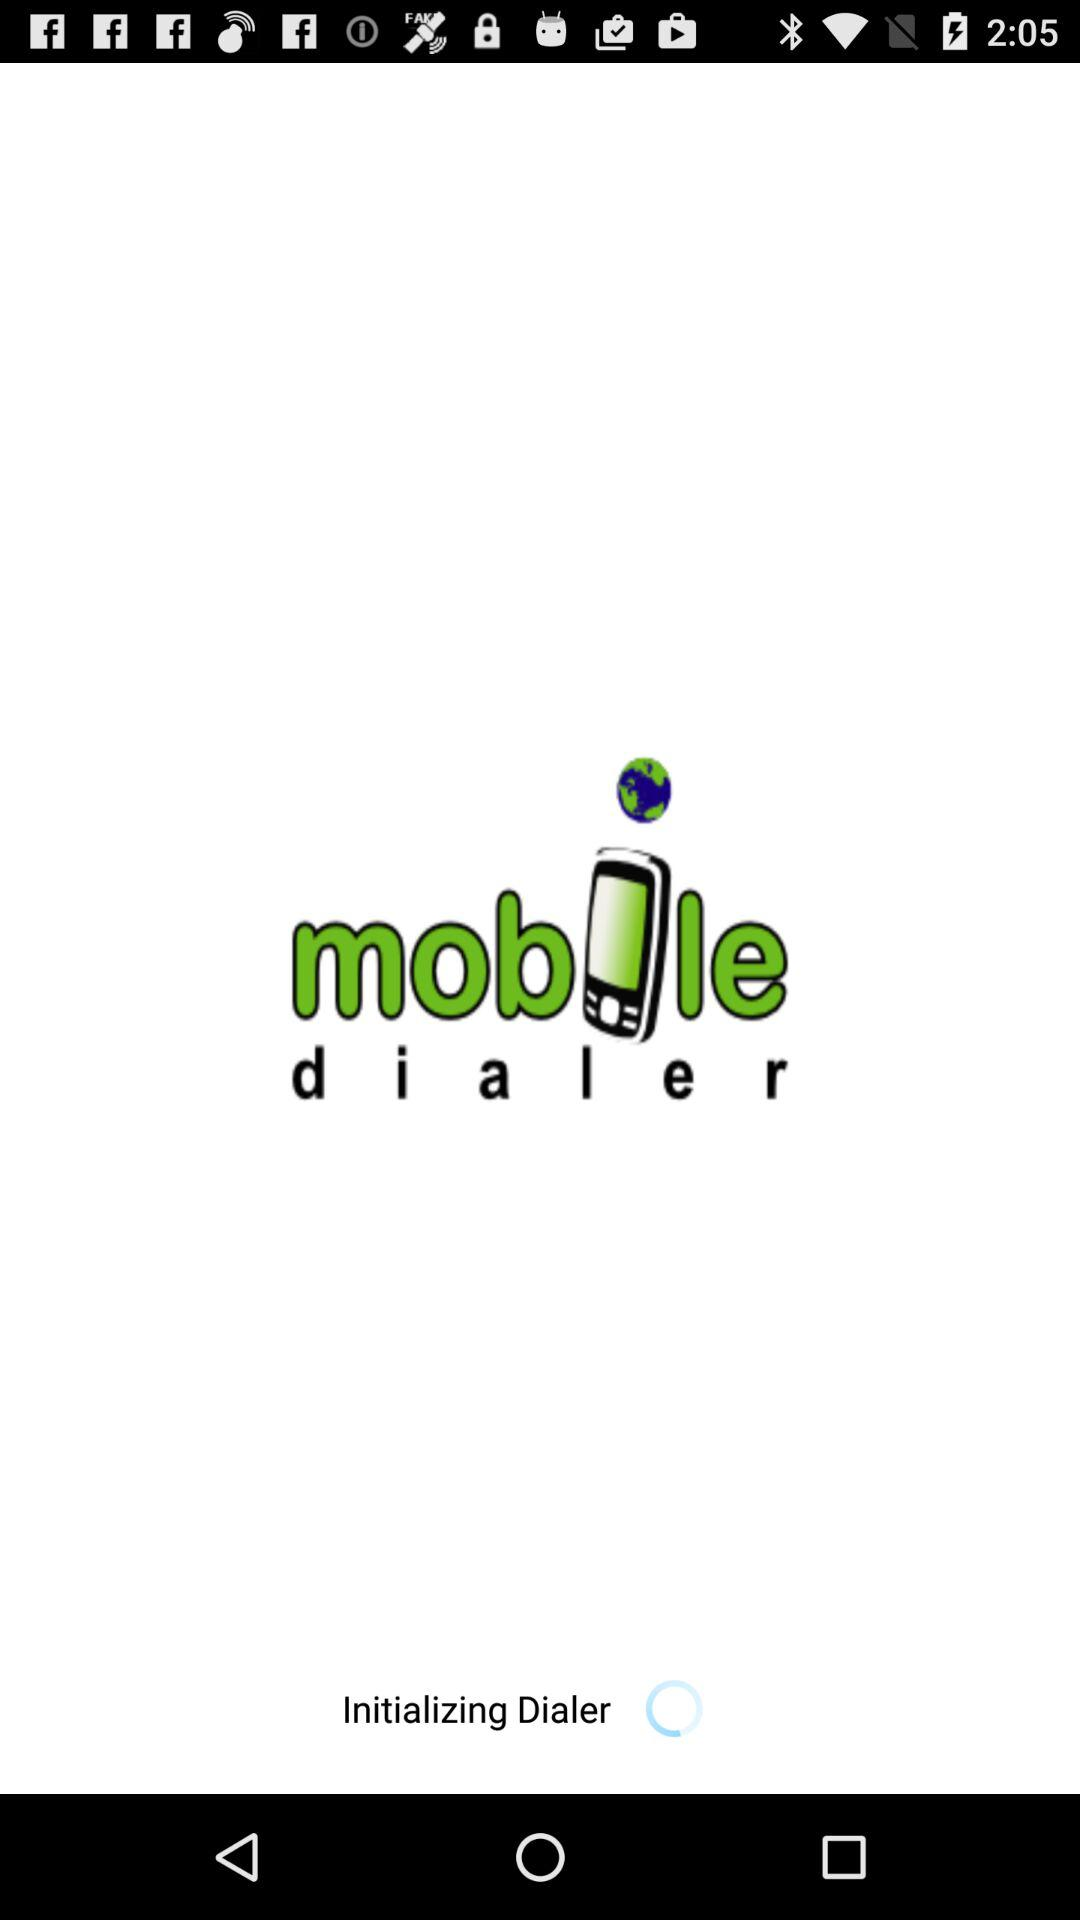What is the application name? The application name is "mobile dialer". 